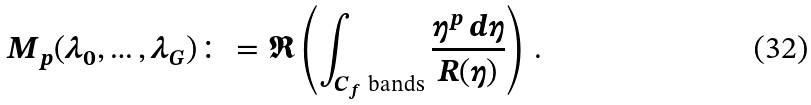<formula> <loc_0><loc_0><loc_500><loc_500>M _ { p } ( \lambda _ { 0 } , \dots , \lambda _ { G } ) \colon = \Re \left ( \int _ { C _ { f } \ \text {bands} } \frac { \eta ^ { p } \, d \eta } { R ( \eta ) } \right ) \, .</formula> 